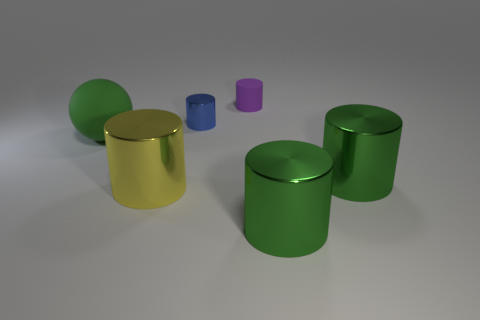Subtract 2 cylinders. How many cylinders are left? 3 Subtract all yellow cylinders. How many cylinders are left? 4 Subtract all blue cylinders. Subtract all blue blocks. How many cylinders are left? 4 Add 2 large metallic cubes. How many objects exist? 8 Subtract all cylinders. How many objects are left? 1 Add 6 big cylinders. How many big cylinders are left? 9 Add 2 blue spheres. How many blue spheres exist? 2 Subtract 0 gray spheres. How many objects are left? 6 Subtract all red metal cubes. Subtract all green metal objects. How many objects are left? 4 